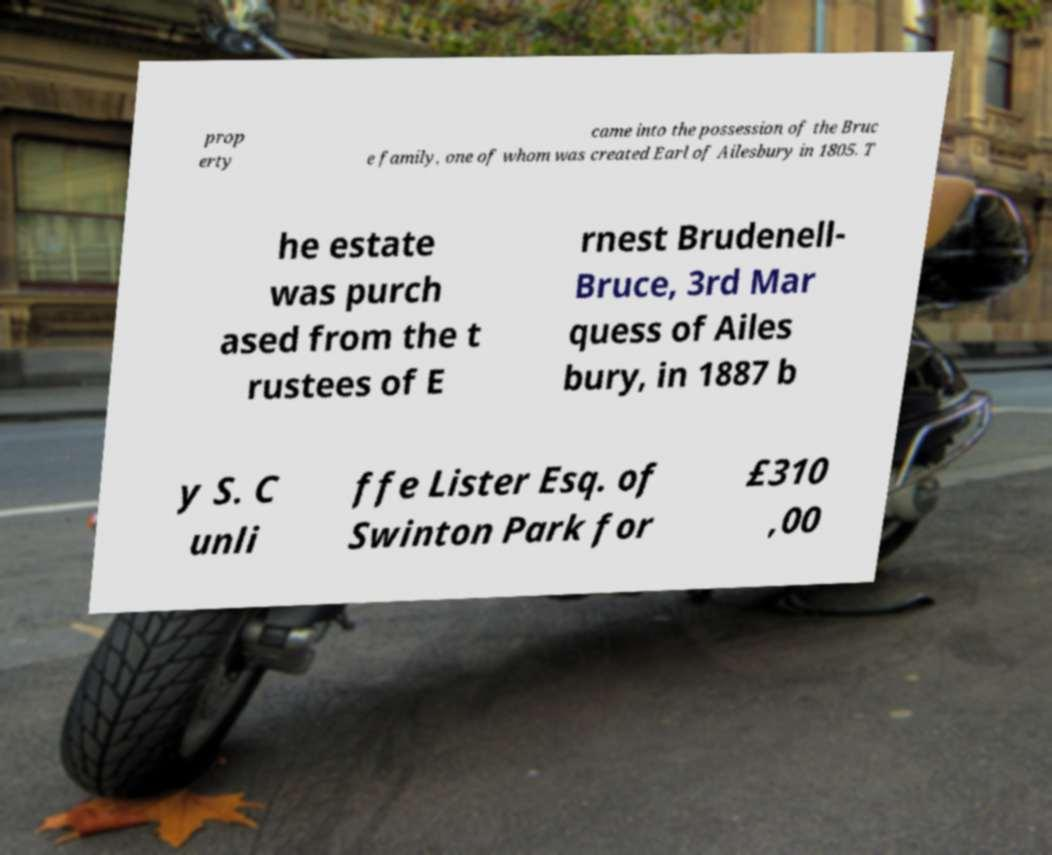I need the written content from this picture converted into text. Can you do that? prop erty came into the possession of the Bruc e family, one of whom was created Earl of Ailesbury in 1805. T he estate was purch ased from the t rustees of E rnest Brudenell- Bruce, 3rd Mar quess of Ailes bury, in 1887 b y S. C unli ffe Lister Esq. of Swinton Park for £310 ,00 